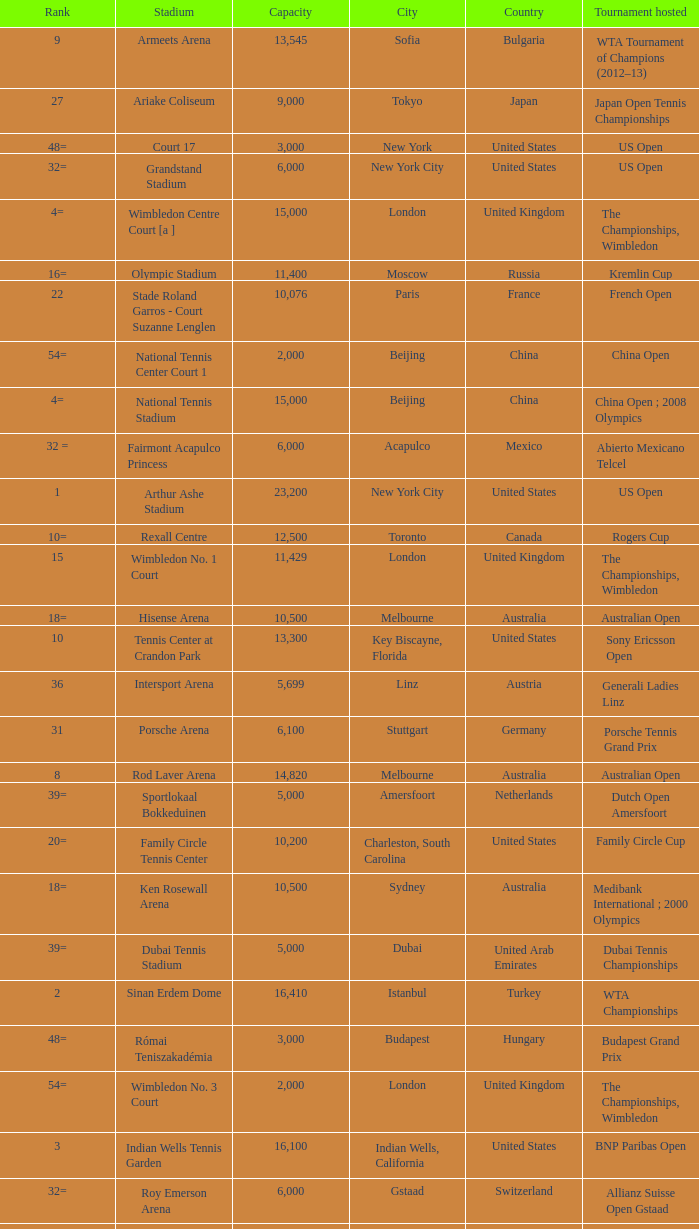What is the average capacity that has rod laver arena as the stadium? 14820.0. 